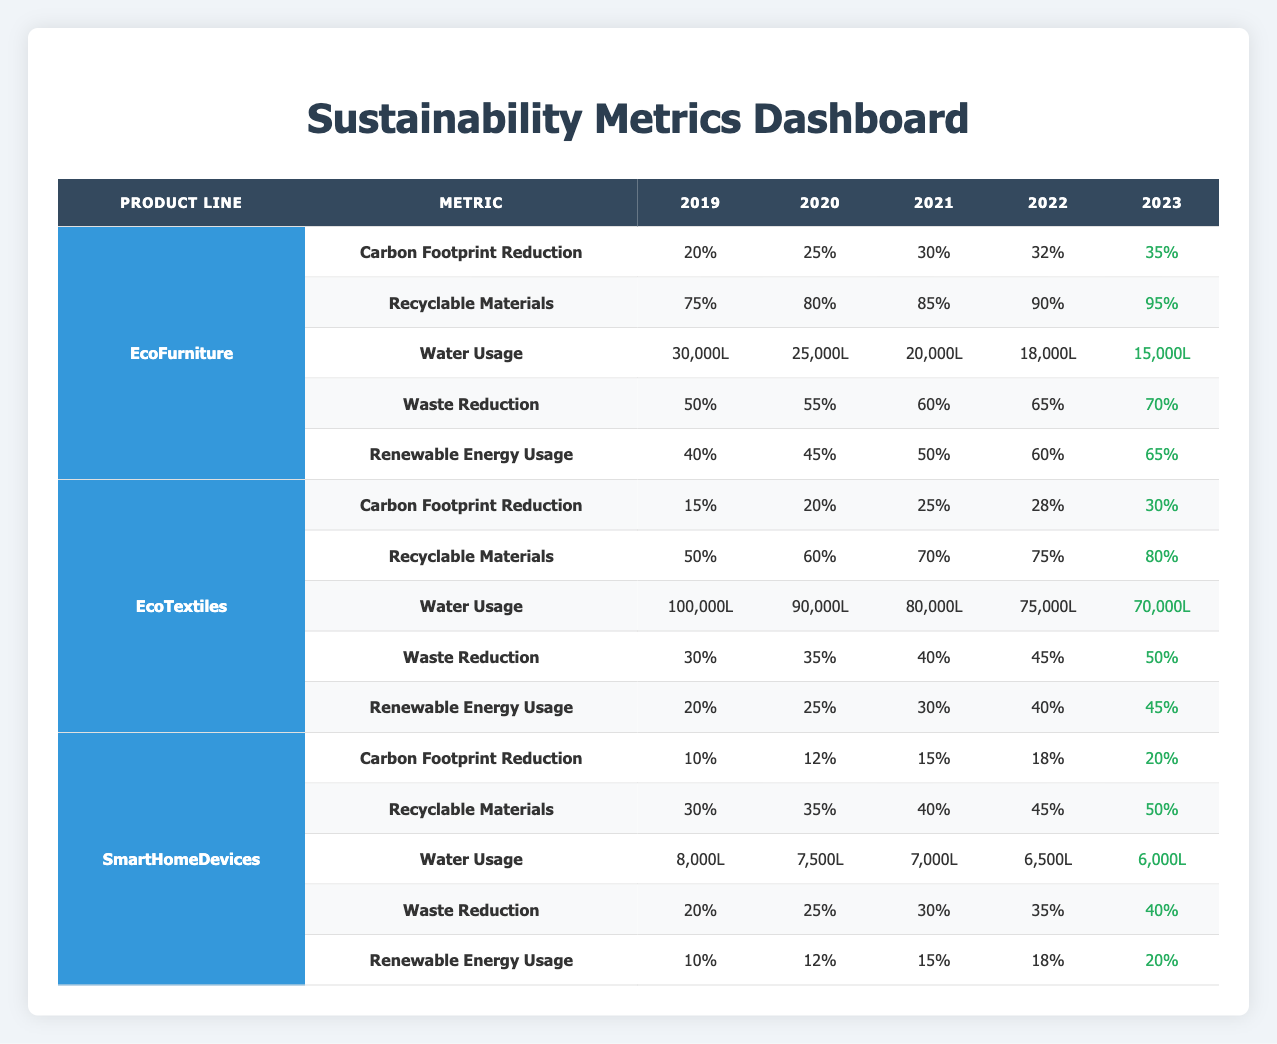What was the carbon footprint reduction for EcoFurniture in 2021? In the table, under the EcoFurniture product line for the year 2021, the carbon footprint reduction is listed as 30%.
Answer: 30% What year had the highest recyclable materials percentage for EcoTextiles? Looking at the EcoTextiles row, the highest percentage of recyclable materials is 80%, which occurred in the year 2023.
Answer: 2023 How much water was used by SmartHomeDevices in 2022? Referring to the SmartHomeDevices section, the water usage for the year 2022 is stated as 6,500L.
Answer: 6,500L Which product line showed the greatest increase in carbon footprint reduction from 2019 to 2023? Calculating the increase for EcoFurniture (20% to 35%) shows a 15% increase, for EcoTextiles (15% to 30%) a 15% increase, and for SmartHomeDevices (10% to 20%) a 10% increase. Since both EcoFurniture and EcoTextiles share the greatest increase of 15%, either can be correct.
Answer: EcoFurniture and EcoTextiles (15%) What is the average water usage for EcoFurniture over the years provided? Summing the water usages for EcoFurniture across all years (30,000 + 25,000 + 20,000 + 18,000 + 15,000 = 108,000L) gives a total of 108,000L. With 5 data points, the average is 108,000L / 5 = 21,600L.
Answer: 21,600L Did the waste reduction for EcoTextiles increase every year from 2019 to 2023? Evaluating the waste reduction values for each year shows 30%, 35%, 40%, 45%, and 50%, which indicates an increase each year. Therefore, the statement is true.
Answer: Yes Which product line had the lowest renewable energy usage in 2019? Checking the renewable energy usage for 2019, EcoFurniture had 40%, EcoTextiles had 20%, and SmartHomeDevices had 10%. Therefore, SmartHomeDevices had the lowest value.
Answer: SmartHomeDevices What was the trend in water usage for EcoFurniture from 2019 to 2023? The water usage went from 30,000L in 2019 to 15,000L in 2023, showing a decreasing trend each year.
Answer: Decreasing trend Which product line was the most sustainable in terms of recyclable materials in 2023? Comparing the recyclable materials in 2023: EcoFurniture has 95%, EcoTextiles has 80%, and SmartHomeDevices has 50%. EcoFurniture has the highest percentage for that year.
Answer: EcoFurniture How does the carbon footprint reduction for SmartHomeDevices compare to EcoFurniture in 2023? For 2023, SmartHomeDevices has a carbon footprint reduction of 20% while EcoFurniture has 35%. EcoFurniture has a higher reduction by 15%.
Answer: EcoFurniture has 15% higher reduction What percentage of recyclable materials did EcoTextiles use in 2022, and how does it compare to the percentage in 2021? EcoTextiles had 75% recyclable materials in 2022 and 70% in 2021, indicating an increase of 5% from the previous year.
Answer: 75%, increased by 5% from 2021 